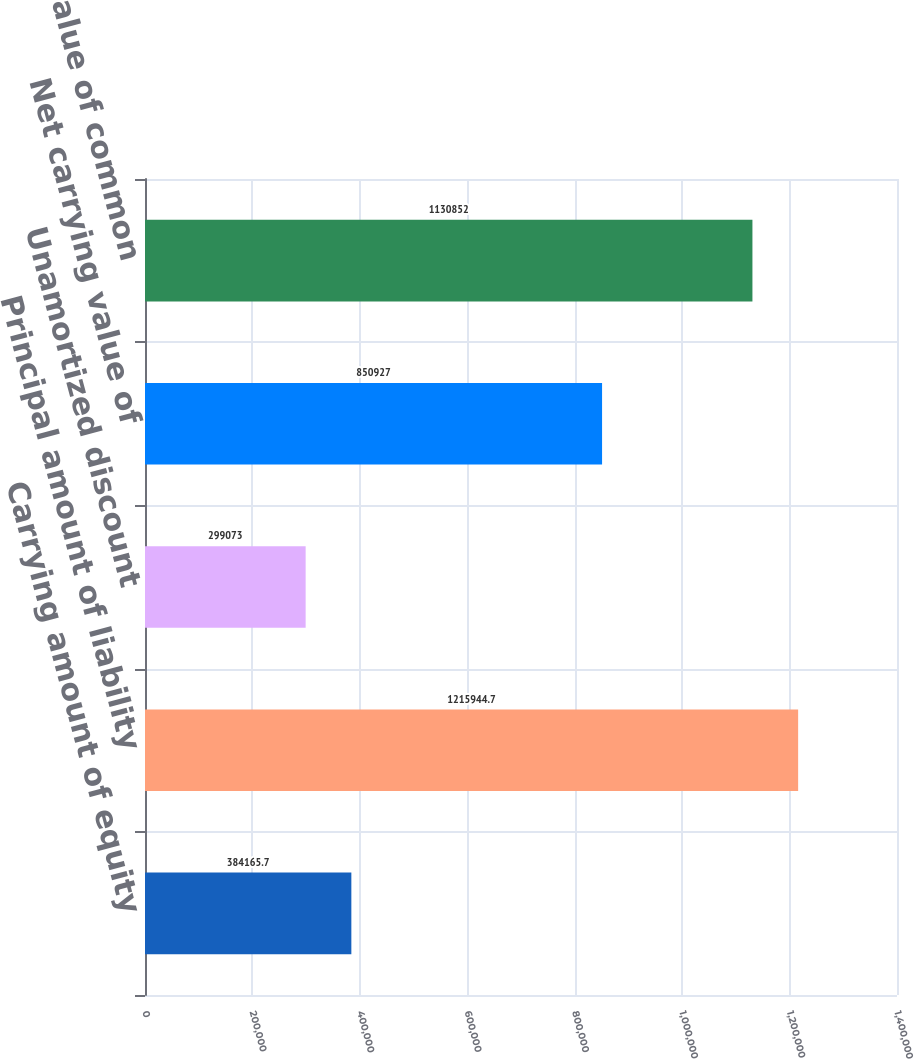Convert chart to OTSL. <chart><loc_0><loc_0><loc_500><loc_500><bar_chart><fcel>Carrying amount of equity<fcel>Principal amount of liability<fcel>Unamortized discount<fcel>Net carrying value of<fcel>If-converted value of common<nl><fcel>384166<fcel>1.21594e+06<fcel>299073<fcel>850927<fcel>1.13085e+06<nl></chart> 